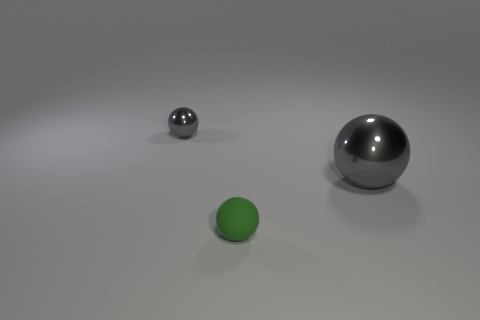Can you describe the texture visible on the surface of the large ball? Certainly! The large ball has a smooth, reflective surface that appears to be metallic, mirroring its environment in its glossy finish. 